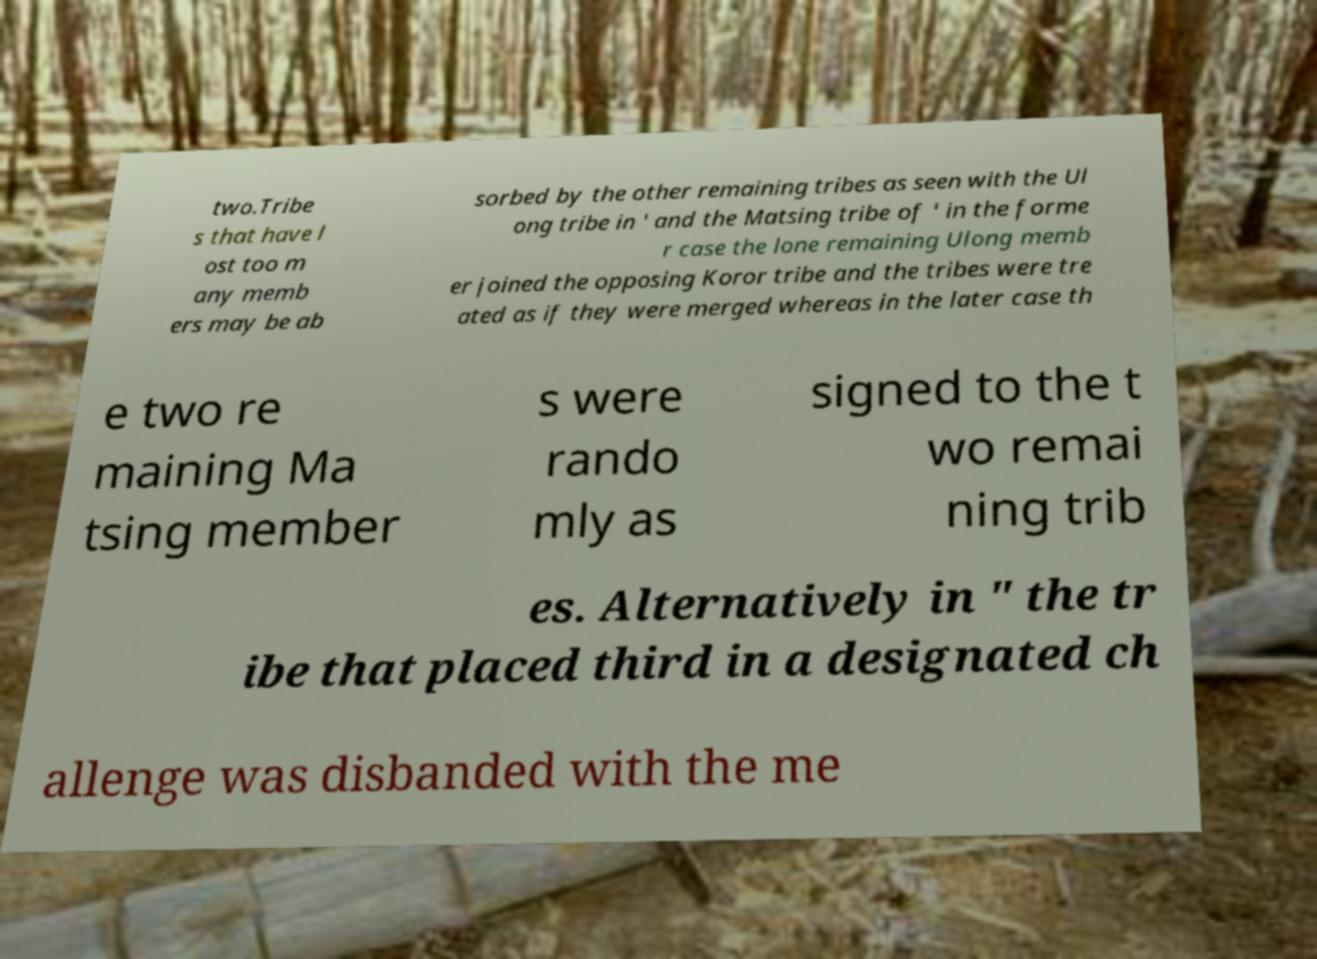I need the written content from this picture converted into text. Can you do that? two.Tribe s that have l ost too m any memb ers may be ab sorbed by the other remaining tribes as seen with the Ul ong tribe in ' and the Matsing tribe of ' in the forme r case the lone remaining Ulong memb er joined the opposing Koror tribe and the tribes were tre ated as if they were merged whereas in the later case th e two re maining Ma tsing member s were rando mly as signed to the t wo remai ning trib es. Alternatively in " the tr ibe that placed third in a designated ch allenge was disbanded with the me 